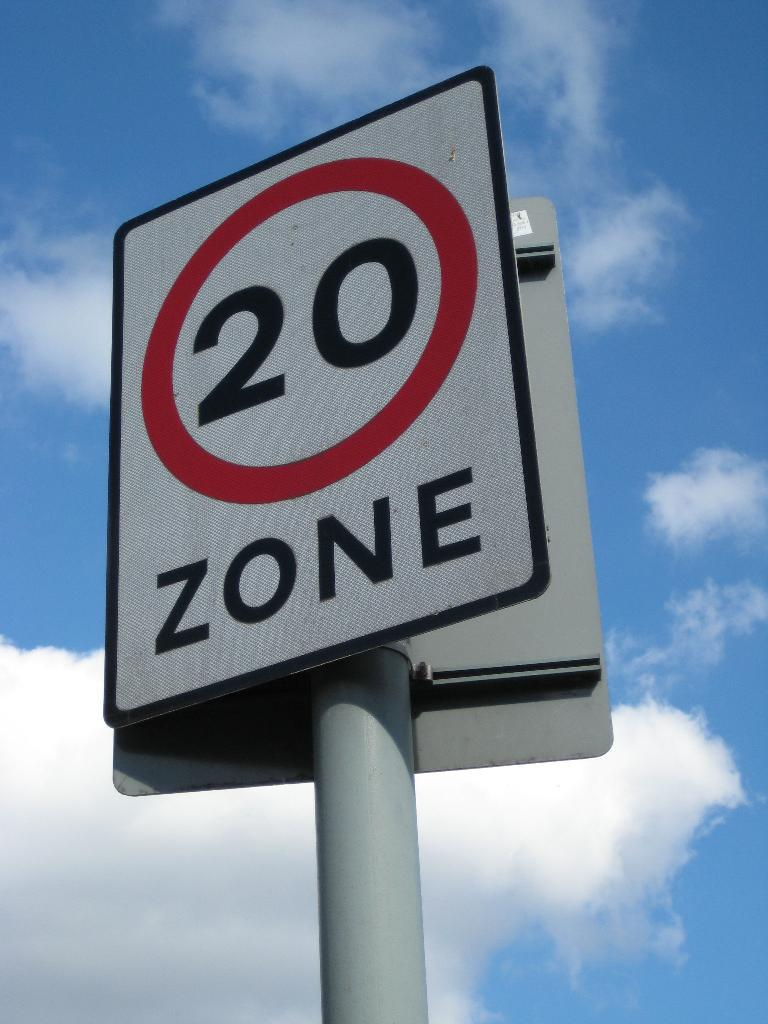<image>
Offer a succinct explanation of the picture presented. A street sign makes this a 20 km/hr zone. 